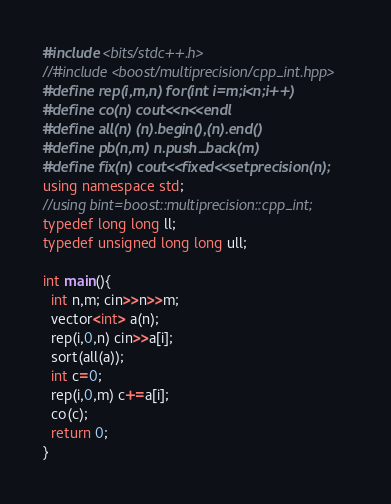Convert code to text. <code><loc_0><loc_0><loc_500><loc_500><_C++_>#include <bits/stdc++.h>
//#include <boost/multiprecision/cpp_int.hpp>
#define rep(i,m,n) for(int i=m;i<n;i++)
#define co(n) cout<<n<<endl
#define all(n) (n).begin(),(n).end()
#define pb(n,m) n.push_back(m)
#define fix(n) cout<<fixed<<setprecision(n);
using namespace std;
//using bint=boost::multiprecision::cpp_int;
typedef long long ll;
typedef unsigned long long ull;

int main(){
  int n,m; cin>>n>>m;
  vector<int> a(n);
  rep(i,0,n) cin>>a[i];
  sort(all(a));
  int c=0;
  rep(i,0,m) c+=a[i];
  co(c);
  return 0;
}</code> 